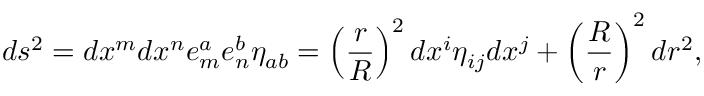<formula> <loc_0><loc_0><loc_500><loc_500>d s ^ { 2 } = d x ^ { m } d x ^ { n } e _ { m } ^ { a } e _ { n } ^ { b } \eta _ { a b } = \left ( { \frac { r } { R } } \right ) ^ { 2 } d x ^ { i } \eta _ { i j } d x ^ { j } + \left ( \frac { R } { r } \right ) ^ { 2 } d r ^ { 2 } ,</formula> 